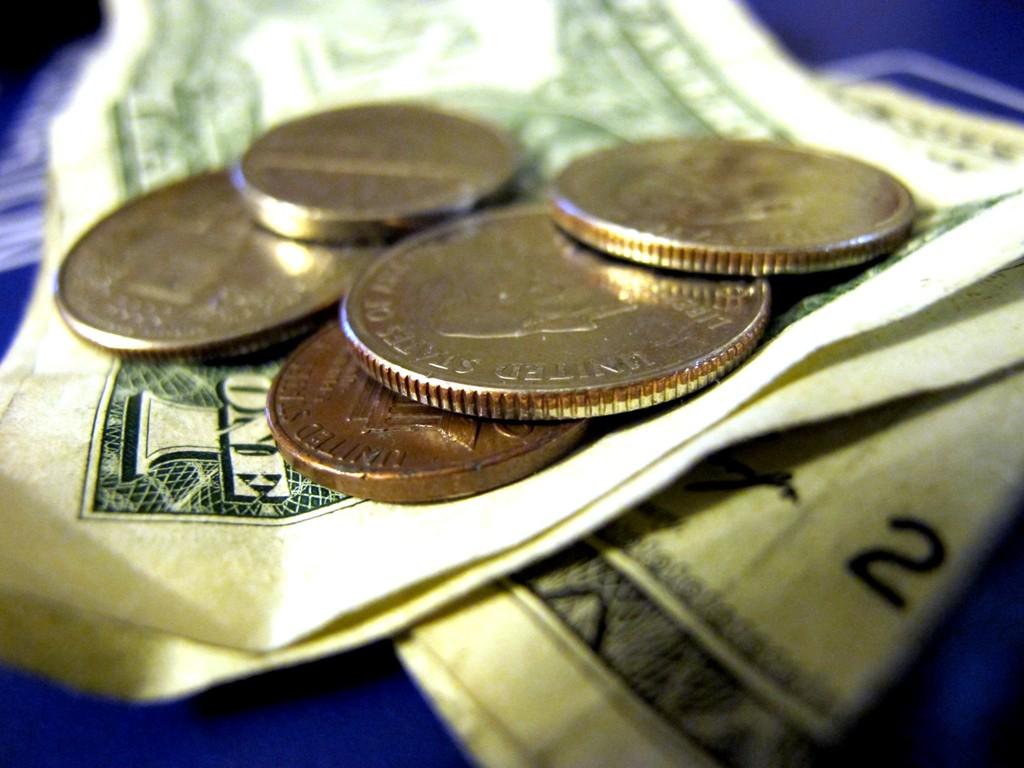How much is the paper money worth?
Provide a succinct answer. One. What country is the big coin from?
Provide a succinct answer. United states. 